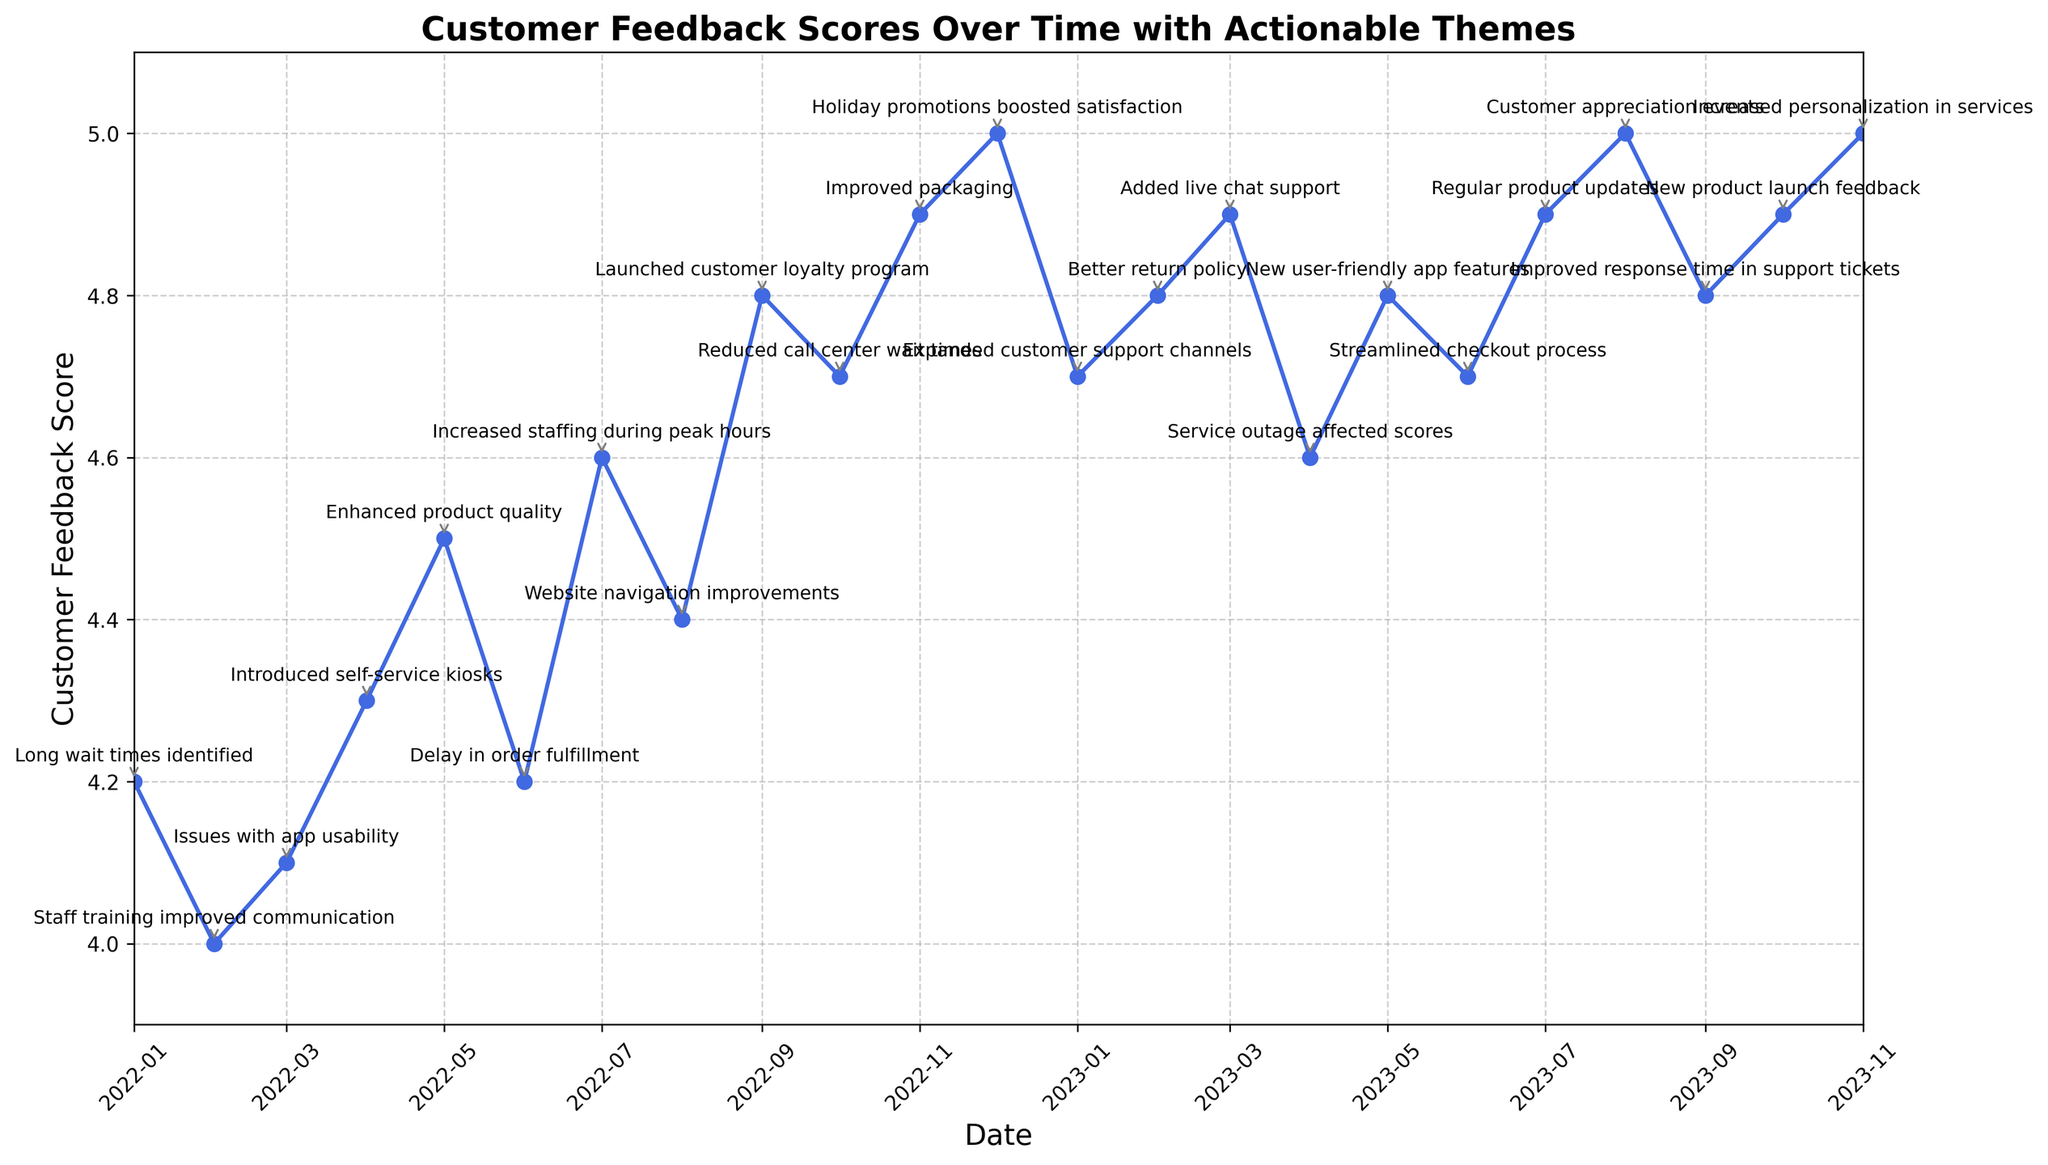What Actionable Theme corresponds to the highest Customer Feedback Score? The highest Customer Feedback Score is 5.0. Checking the corresponding Actionable Theme for these values, we see it is related to "Holiday promotions boosted satisfaction," "Customer appreciation events," and "Increased personalization in services."
Answer: Holiday promotions boosted satisfaction, Customer appreciation events, Increased personalization in services What was the Customer Feedback Score in January 2022? Looking at the plot for January 2022, the Customer Feedback Score is 4.2.
Answer: 4.2 Which month saw the largest increase in the Customer Feedback Score? Comparing the scores, the largest increase appears between June 2022 (4.2) and July 2022 (4.6). Calculate the difference: 4.6 - 4.2 = 0.4.
Answer: July 2022 How did the Customer Feedback Score change after introducing self-service kiosks in April 2022? In April 2022, the score was 4.3. In May 2022, it increased to 4.5. Calculating the change: 4.5 - 4.3 = 0.2.
Answer: Increased by 0.2 What is the median Customer Feedback Score for the entire period? Listing all scores in order and finding the middle value: 4.0, 4.1, 4.2, 4.2, 4.3, 4.4, 4.5, 4.6, 4.6, 4.7, 4.7, 4.8, 4.8, 4.8, 4.9, 4.9, 4.9, 4.9, 5.0, 5.0, 5.0. The median value, in this case, is the 11th value, which is 4.7.
Answer: 4.7 After which Actionable Theme in 2023 did the Customer Feedback Score remain constant at 4.9? Look at the yearly 2023 entries and the associated themes. The score is 4.9 after the theme "Added live chat support" in March 2023 and stayed constant with "Regular product updates" in July 2023 and "New product launch feedback" in October 2023.
Answer: Added live chat support What is the total change in Customer Feedback Score from January 2022 to November 2023? Initial score in January 2022 is 4.2 and the final score in November 2023 is 5.0. Calculating the change: 5.0 - 4.2 = 0.8.
Answer: 0.8 Which two months have the same Customer Feedback Score with different Actionable Themes? Identifying months with the same scores from the chart, April 2023 (service outage affected scores) and June 2023 (streamlined checkout process), both have scores of 4.6.
Answer: April 2023 and June 2023 When did the Customer Feedback Score first reach 4.8 and what Actionable Theme was implemented? The score of 4.8 is first reached in September 2022. The corresponding Actionable Theme is "Launched customer loyalty program."
Answer: September 2022, Launched customer loyalty program 